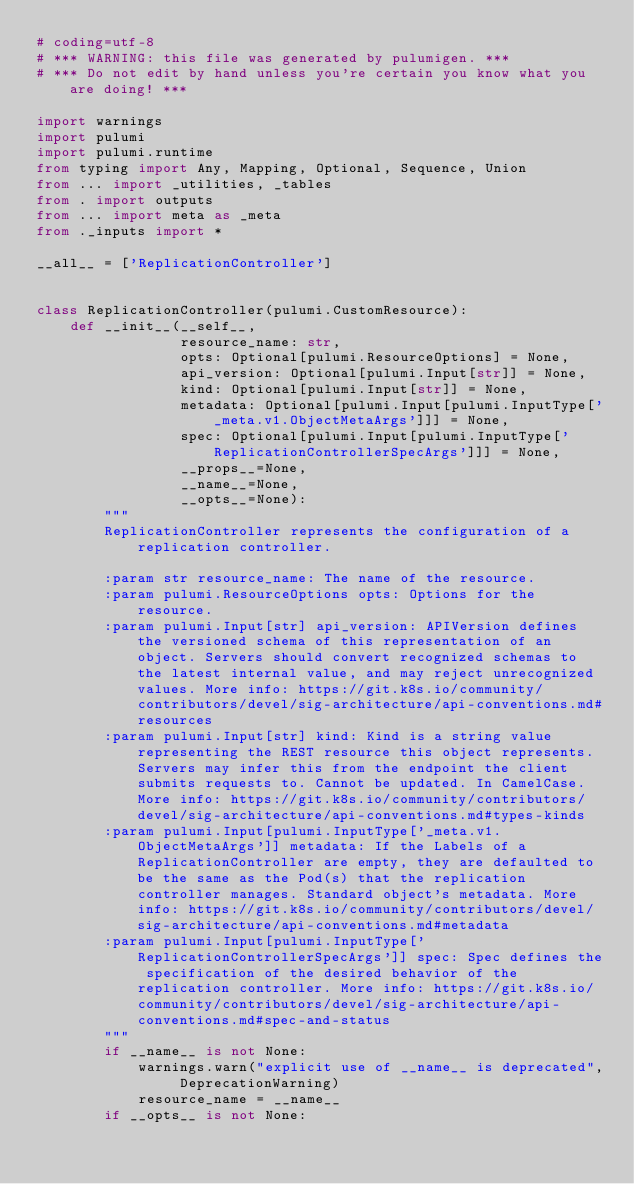<code> <loc_0><loc_0><loc_500><loc_500><_Python_># coding=utf-8
# *** WARNING: this file was generated by pulumigen. ***
# *** Do not edit by hand unless you're certain you know what you are doing! ***

import warnings
import pulumi
import pulumi.runtime
from typing import Any, Mapping, Optional, Sequence, Union
from ... import _utilities, _tables
from . import outputs
from ... import meta as _meta
from ._inputs import *

__all__ = ['ReplicationController']


class ReplicationController(pulumi.CustomResource):
    def __init__(__self__,
                 resource_name: str,
                 opts: Optional[pulumi.ResourceOptions] = None,
                 api_version: Optional[pulumi.Input[str]] = None,
                 kind: Optional[pulumi.Input[str]] = None,
                 metadata: Optional[pulumi.Input[pulumi.InputType['_meta.v1.ObjectMetaArgs']]] = None,
                 spec: Optional[pulumi.Input[pulumi.InputType['ReplicationControllerSpecArgs']]] = None,
                 __props__=None,
                 __name__=None,
                 __opts__=None):
        """
        ReplicationController represents the configuration of a replication controller.

        :param str resource_name: The name of the resource.
        :param pulumi.ResourceOptions opts: Options for the resource.
        :param pulumi.Input[str] api_version: APIVersion defines the versioned schema of this representation of an object. Servers should convert recognized schemas to the latest internal value, and may reject unrecognized values. More info: https://git.k8s.io/community/contributors/devel/sig-architecture/api-conventions.md#resources
        :param pulumi.Input[str] kind: Kind is a string value representing the REST resource this object represents. Servers may infer this from the endpoint the client submits requests to. Cannot be updated. In CamelCase. More info: https://git.k8s.io/community/contributors/devel/sig-architecture/api-conventions.md#types-kinds
        :param pulumi.Input[pulumi.InputType['_meta.v1.ObjectMetaArgs']] metadata: If the Labels of a ReplicationController are empty, they are defaulted to be the same as the Pod(s) that the replication controller manages. Standard object's metadata. More info: https://git.k8s.io/community/contributors/devel/sig-architecture/api-conventions.md#metadata
        :param pulumi.Input[pulumi.InputType['ReplicationControllerSpecArgs']] spec: Spec defines the specification of the desired behavior of the replication controller. More info: https://git.k8s.io/community/contributors/devel/sig-architecture/api-conventions.md#spec-and-status
        """
        if __name__ is not None:
            warnings.warn("explicit use of __name__ is deprecated", DeprecationWarning)
            resource_name = __name__
        if __opts__ is not None:</code> 